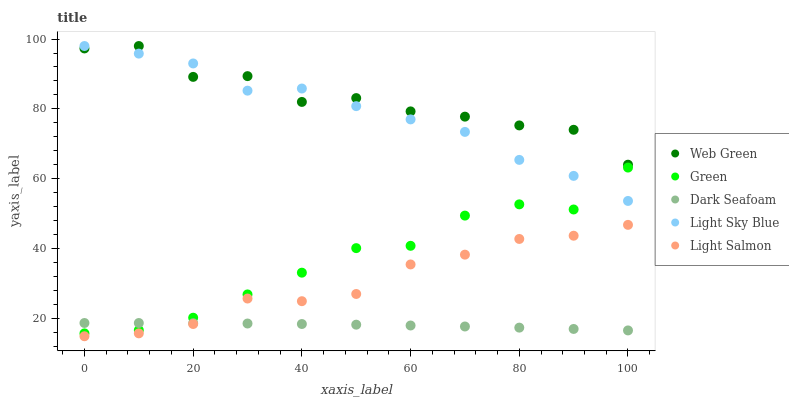Does Dark Seafoam have the minimum area under the curve?
Answer yes or no. Yes. Does Web Green have the maximum area under the curve?
Answer yes or no. Yes. Does Light Sky Blue have the minimum area under the curve?
Answer yes or no. No. Does Light Sky Blue have the maximum area under the curve?
Answer yes or no. No. Is Dark Seafoam the smoothest?
Answer yes or no. Yes. Is Web Green the roughest?
Answer yes or no. Yes. Is Light Sky Blue the smoothest?
Answer yes or no. No. Is Light Sky Blue the roughest?
Answer yes or no. No. Does Light Salmon have the lowest value?
Answer yes or no. Yes. Does Light Sky Blue have the lowest value?
Answer yes or no. No. Does Web Green have the highest value?
Answer yes or no. Yes. Does Green have the highest value?
Answer yes or no. No. Is Dark Seafoam less than Web Green?
Answer yes or no. Yes. Is Light Sky Blue greater than Dark Seafoam?
Answer yes or no. Yes. Does Light Sky Blue intersect Web Green?
Answer yes or no. Yes. Is Light Sky Blue less than Web Green?
Answer yes or no. No. Is Light Sky Blue greater than Web Green?
Answer yes or no. No. Does Dark Seafoam intersect Web Green?
Answer yes or no. No. 